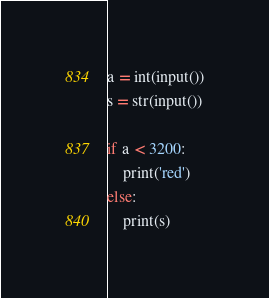Convert code to text. <code><loc_0><loc_0><loc_500><loc_500><_Python_>a = int(input())
s = str(input())

if a < 3200:
    print('red')
else:
    print(s)</code> 